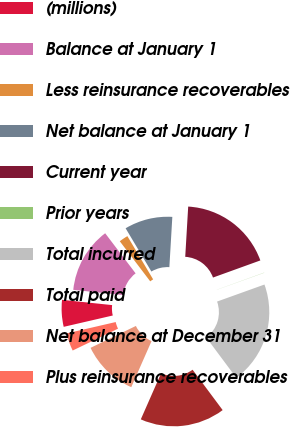<chart> <loc_0><loc_0><loc_500><loc_500><pie_chart><fcel>(millions)<fcel>Balance at January 1<fcel>Less reinsurance recoverables<fcel>Net balance at January 1<fcel>Current year<fcel>Prior years<fcel>Total incurred<fcel>Total paid<fcel>Net balance at December 31<fcel>Plus reinsurance recoverables<nl><fcel>5.29%<fcel>12.99%<fcel>1.78%<fcel>9.49%<fcel>18.54%<fcel>0.03%<fcel>20.3%<fcel>16.79%<fcel>11.24%<fcel>3.54%<nl></chart> 